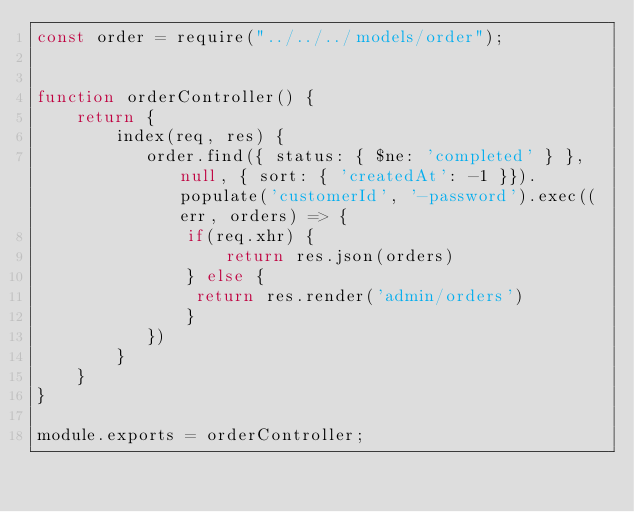Convert code to text. <code><loc_0><loc_0><loc_500><loc_500><_JavaScript_>const order = require("../../../models/order");


function orderController() {
    return {
        index(req, res) {
           order.find({ status: { $ne: 'completed' } }, null, { sort: { 'createdAt': -1 }}).populate('customerId', '-password').exec((err, orders) => {
               if(req.xhr) {
                   return res.json(orders)
               } else {
                return res.render('admin/orders')
               } 
           })
        }
    }
}

module.exports = orderController;</code> 